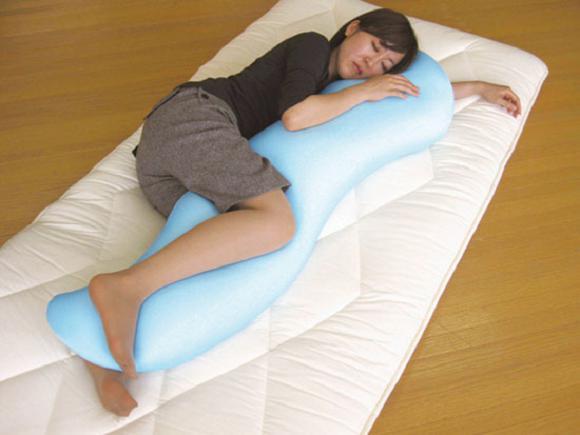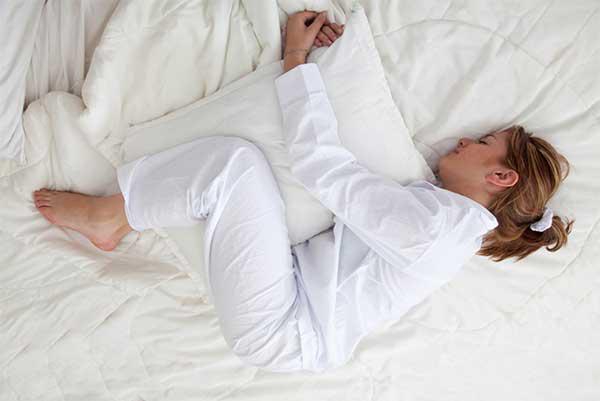The first image is the image on the left, the second image is the image on the right. Considering the images on both sides, is "A woman is lying on her left side with a pillow as large as her." valid? Answer yes or no. Yes. The first image is the image on the left, the second image is the image on the right. For the images shown, is this caption "There are three people." true? Answer yes or no. No. 